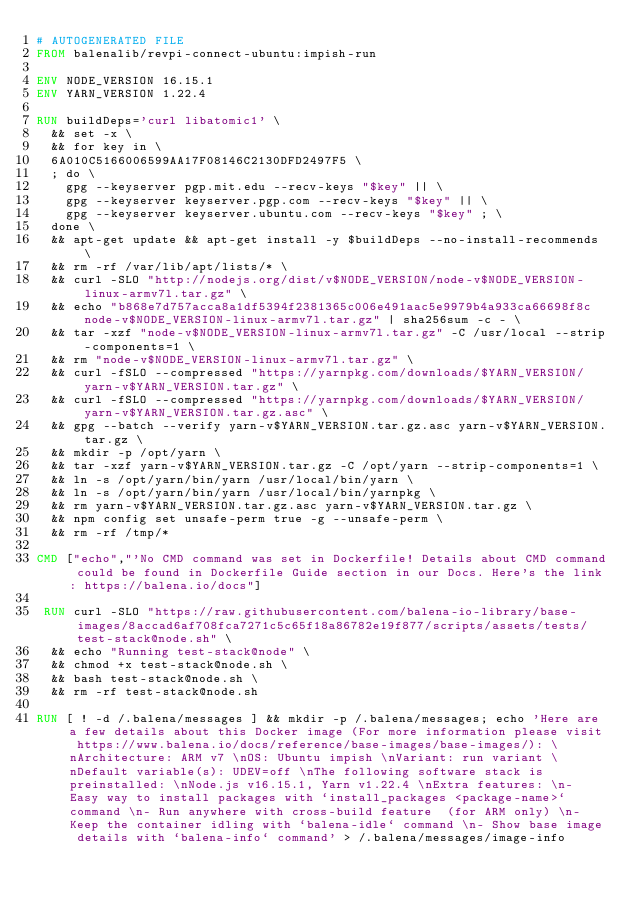Convert code to text. <code><loc_0><loc_0><loc_500><loc_500><_Dockerfile_># AUTOGENERATED FILE
FROM balenalib/revpi-connect-ubuntu:impish-run

ENV NODE_VERSION 16.15.1
ENV YARN_VERSION 1.22.4

RUN buildDeps='curl libatomic1' \
	&& set -x \
	&& for key in \
	6A010C5166006599AA17F08146C2130DFD2497F5 \
	; do \
		gpg --keyserver pgp.mit.edu --recv-keys "$key" || \
		gpg --keyserver keyserver.pgp.com --recv-keys "$key" || \
		gpg --keyserver keyserver.ubuntu.com --recv-keys "$key" ; \
	done \
	&& apt-get update && apt-get install -y $buildDeps --no-install-recommends \
	&& rm -rf /var/lib/apt/lists/* \
	&& curl -SLO "http://nodejs.org/dist/v$NODE_VERSION/node-v$NODE_VERSION-linux-armv7l.tar.gz" \
	&& echo "b868e7d757acca8a1df5394f2381365c006e491aac5e9979b4a933ca66698f8c  node-v$NODE_VERSION-linux-armv7l.tar.gz" | sha256sum -c - \
	&& tar -xzf "node-v$NODE_VERSION-linux-armv7l.tar.gz" -C /usr/local --strip-components=1 \
	&& rm "node-v$NODE_VERSION-linux-armv7l.tar.gz" \
	&& curl -fSLO --compressed "https://yarnpkg.com/downloads/$YARN_VERSION/yarn-v$YARN_VERSION.tar.gz" \
	&& curl -fSLO --compressed "https://yarnpkg.com/downloads/$YARN_VERSION/yarn-v$YARN_VERSION.tar.gz.asc" \
	&& gpg --batch --verify yarn-v$YARN_VERSION.tar.gz.asc yarn-v$YARN_VERSION.tar.gz \
	&& mkdir -p /opt/yarn \
	&& tar -xzf yarn-v$YARN_VERSION.tar.gz -C /opt/yarn --strip-components=1 \
	&& ln -s /opt/yarn/bin/yarn /usr/local/bin/yarn \
	&& ln -s /opt/yarn/bin/yarn /usr/local/bin/yarnpkg \
	&& rm yarn-v$YARN_VERSION.tar.gz.asc yarn-v$YARN_VERSION.tar.gz \
	&& npm config set unsafe-perm true -g --unsafe-perm \
	&& rm -rf /tmp/*

CMD ["echo","'No CMD command was set in Dockerfile! Details about CMD command could be found in Dockerfile Guide section in our Docs. Here's the link: https://balena.io/docs"]

 RUN curl -SLO "https://raw.githubusercontent.com/balena-io-library/base-images/8accad6af708fca7271c5c65f18a86782e19f877/scripts/assets/tests/test-stack@node.sh" \
  && echo "Running test-stack@node" \
  && chmod +x test-stack@node.sh \
  && bash test-stack@node.sh \
  && rm -rf test-stack@node.sh 

RUN [ ! -d /.balena/messages ] && mkdir -p /.balena/messages; echo 'Here are a few details about this Docker image (For more information please visit https://www.balena.io/docs/reference/base-images/base-images/): \nArchitecture: ARM v7 \nOS: Ubuntu impish \nVariant: run variant \nDefault variable(s): UDEV=off \nThe following software stack is preinstalled: \nNode.js v16.15.1, Yarn v1.22.4 \nExtra features: \n- Easy way to install packages with `install_packages <package-name>` command \n- Run anywhere with cross-build feature  (for ARM only) \n- Keep the container idling with `balena-idle` command \n- Show base image details with `balena-info` command' > /.balena/messages/image-info</code> 